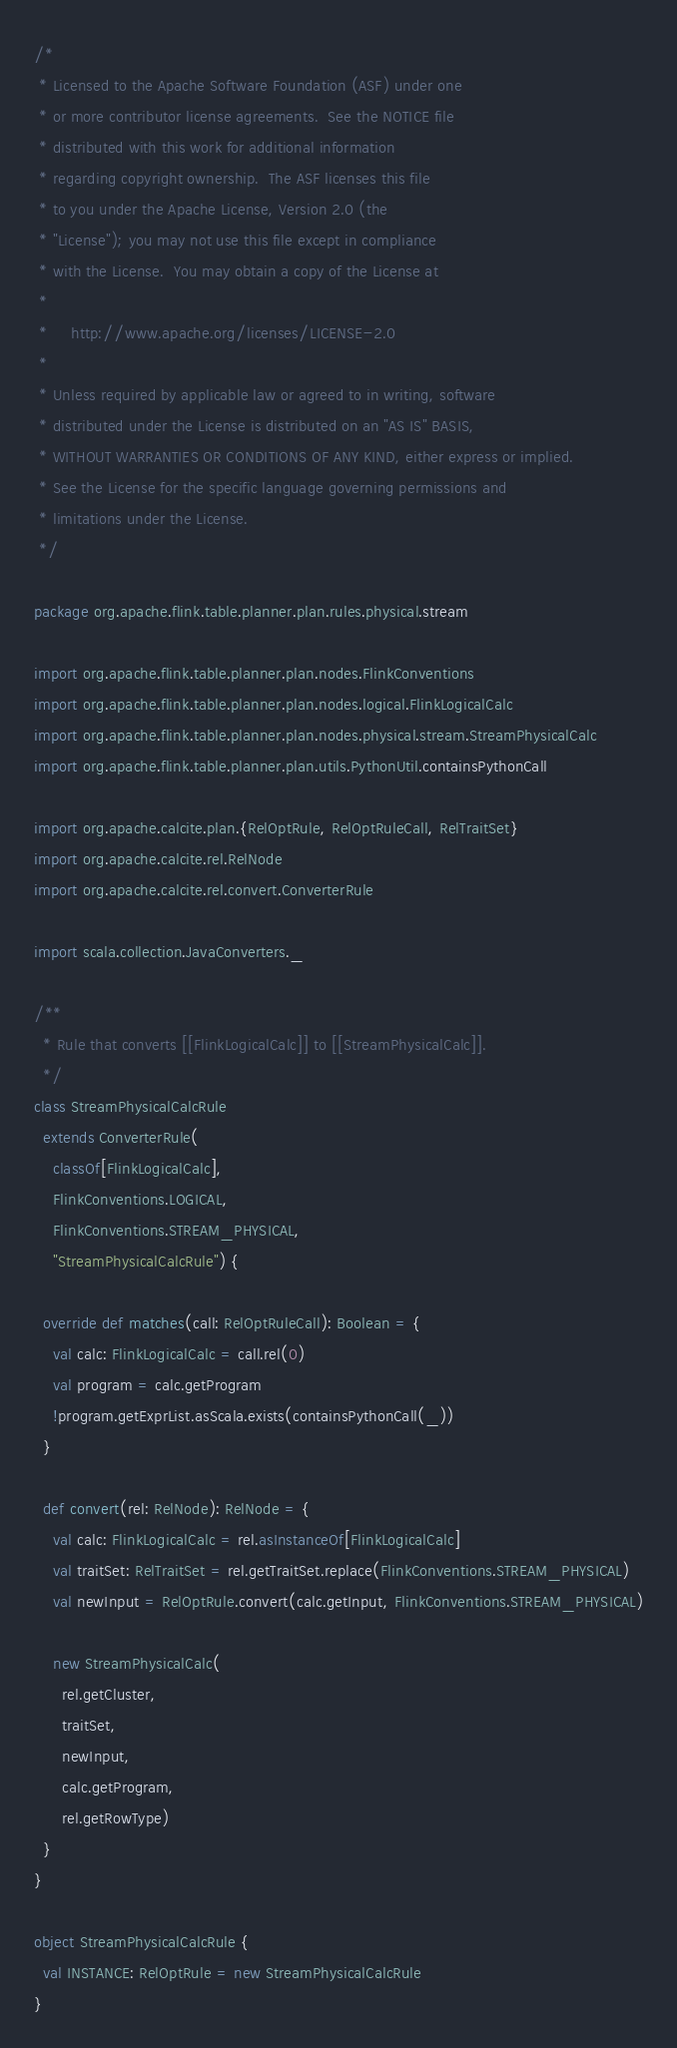<code> <loc_0><loc_0><loc_500><loc_500><_Scala_>/*
 * Licensed to the Apache Software Foundation (ASF) under one
 * or more contributor license agreements.  See the NOTICE file
 * distributed with this work for additional information
 * regarding copyright ownership.  The ASF licenses this file
 * to you under the Apache License, Version 2.0 (the
 * "License"); you may not use this file except in compliance
 * with the License.  You may obtain a copy of the License at
 *
 *     http://www.apache.org/licenses/LICENSE-2.0
 *
 * Unless required by applicable law or agreed to in writing, software
 * distributed under the License is distributed on an "AS IS" BASIS,
 * WITHOUT WARRANTIES OR CONDITIONS OF ANY KIND, either express or implied.
 * See the License for the specific language governing permissions and
 * limitations under the License.
 */

package org.apache.flink.table.planner.plan.rules.physical.stream

import org.apache.flink.table.planner.plan.nodes.FlinkConventions
import org.apache.flink.table.planner.plan.nodes.logical.FlinkLogicalCalc
import org.apache.flink.table.planner.plan.nodes.physical.stream.StreamPhysicalCalc
import org.apache.flink.table.planner.plan.utils.PythonUtil.containsPythonCall

import org.apache.calcite.plan.{RelOptRule, RelOptRuleCall, RelTraitSet}
import org.apache.calcite.rel.RelNode
import org.apache.calcite.rel.convert.ConverterRule

import scala.collection.JavaConverters._

/**
  * Rule that converts [[FlinkLogicalCalc]] to [[StreamPhysicalCalc]].
  */
class StreamPhysicalCalcRule
  extends ConverterRule(
    classOf[FlinkLogicalCalc],
    FlinkConventions.LOGICAL,
    FlinkConventions.STREAM_PHYSICAL,
    "StreamPhysicalCalcRule") {

  override def matches(call: RelOptRuleCall): Boolean = {
    val calc: FlinkLogicalCalc = call.rel(0)
    val program = calc.getProgram
    !program.getExprList.asScala.exists(containsPythonCall(_))
  }

  def convert(rel: RelNode): RelNode = {
    val calc: FlinkLogicalCalc = rel.asInstanceOf[FlinkLogicalCalc]
    val traitSet: RelTraitSet = rel.getTraitSet.replace(FlinkConventions.STREAM_PHYSICAL)
    val newInput = RelOptRule.convert(calc.getInput, FlinkConventions.STREAM_PHYSICAL)

    new StreamPhysicalCalc(
      rel.getCluster,
      traitSet,
      newInput,
      calc.getProgram,
      rel.getRowType)
  }
}

object StreamPhysicalCalcRule {
  val INSTANCE: RelOptRule = new StreamPhysicalCalcRule
}
</code> 